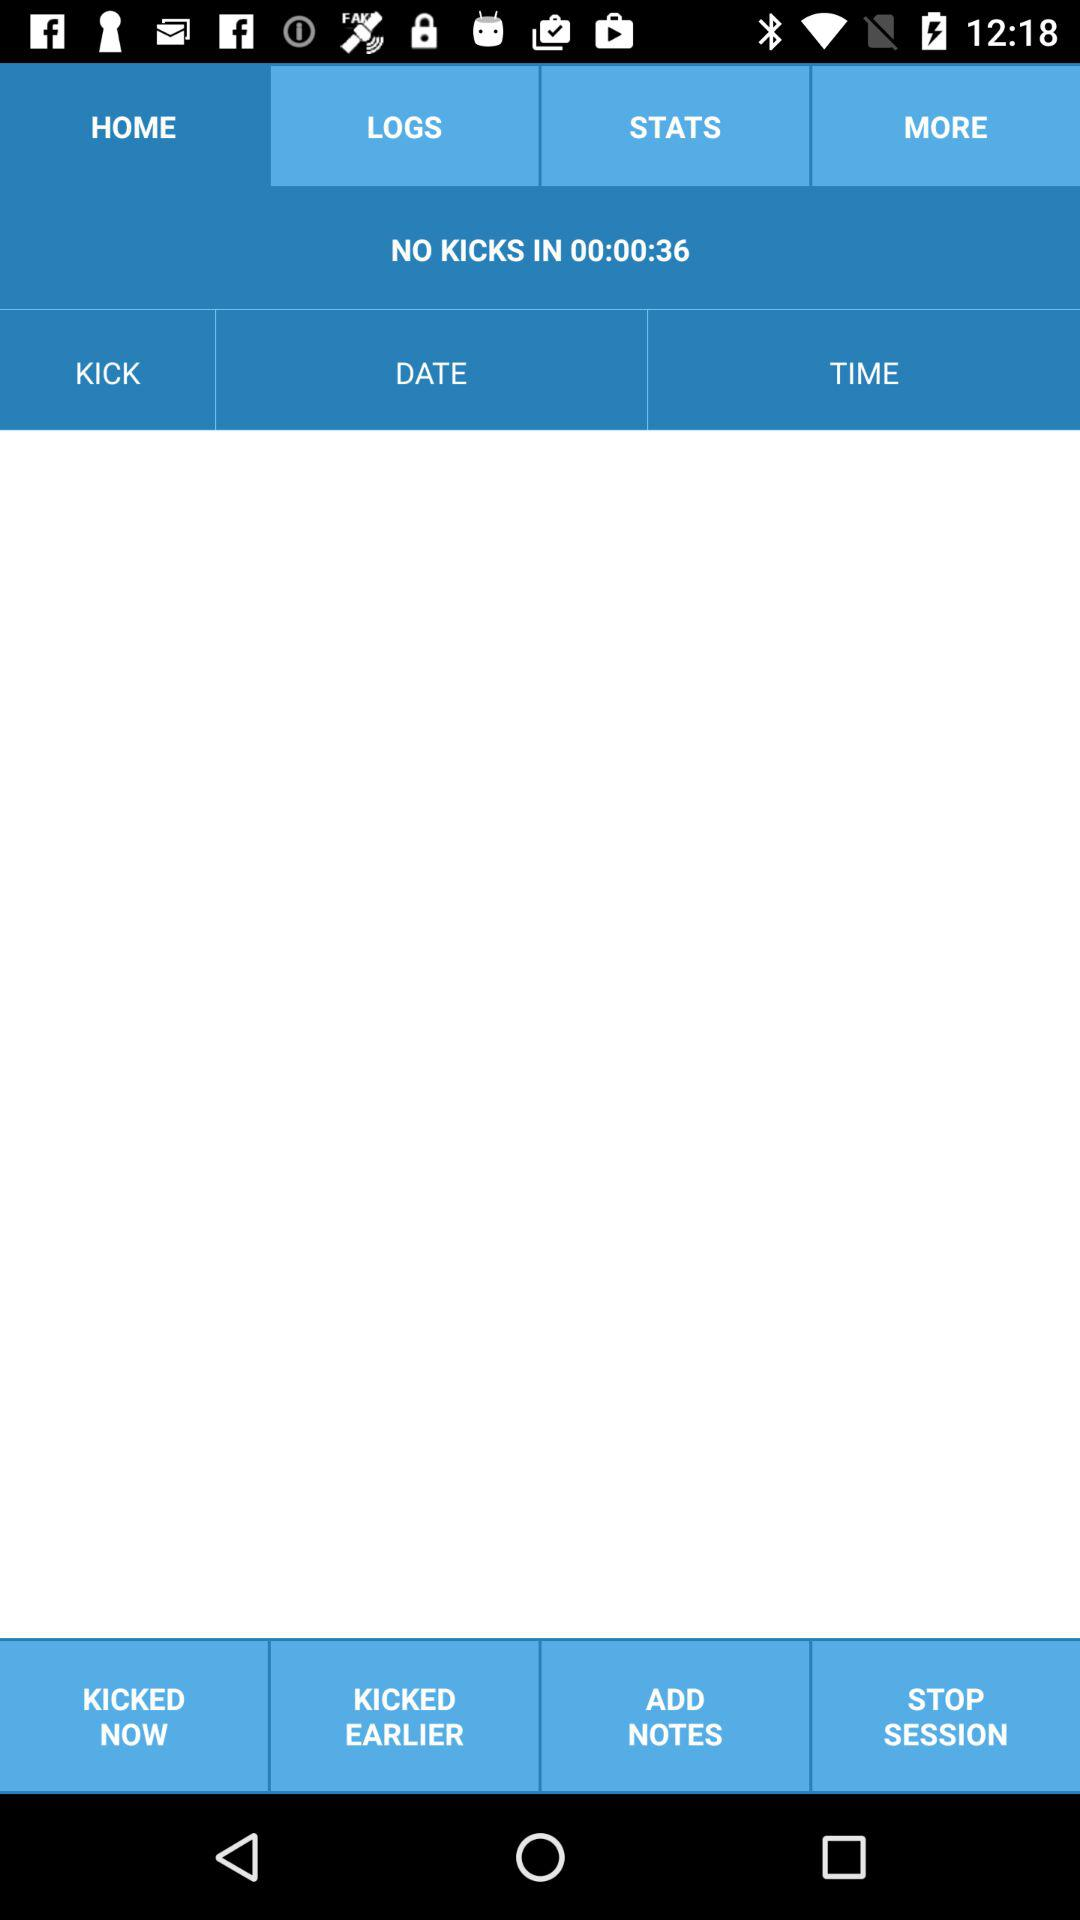What is the elapsed time for no kicks? The elapsed time for no kicks is 00:00:36. 